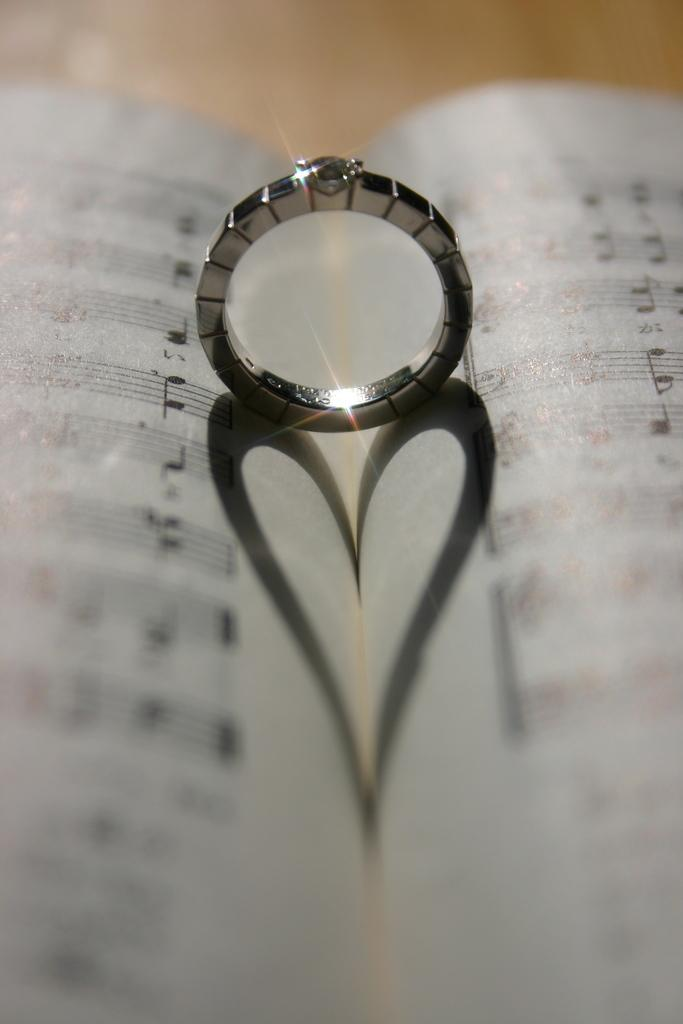What object can be seen in the image that is typically used for reading? There is a book in the image that is typically used for reading. What other object is present in the image? There is a ring in the image. How are the ring and the book related in the image? The ring is on the book. What can be observed about the ring's presence on the book? The shadow of the ring is visible on the book. What type of weather can be seen in the image? There is no weather visible in the image, as it only features a book with a ring on it. How many houses are present in the image? There are no houses present in the image; it only features a book with a ring on it. 